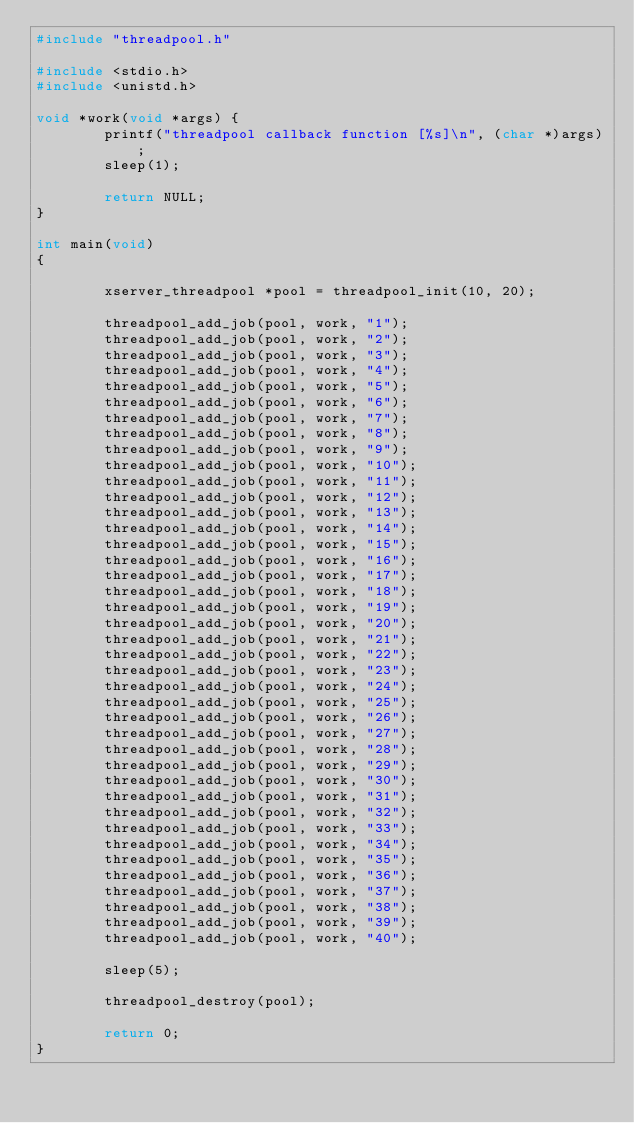<code> <loc_0><loc_0><loc_500><loc_500><_C_>#include "threadpool.h"

#include <stdio.h>
#include <unistd.h>

void *work(void *args) {
        printf("threadpool callback function [%s]\n", (char *)args);
        sleep(1);

        return NULL;
}

int main(void)
{

        xserver_threadpool *pool = threadpool_init(10, 20);

        threadpool_add_job(pool, work, "1");
        threadpool_add_job(pool, work, "2");
        threadpool_add_job(pool, work, "3");
        threadpool_add_job(pool, work, "4");
        threadpool_add_job(pool, work, "5");
        threadpool_add_job(pool, work, "6");
        threadpool_add_job(pool, work, "7");
        threadpool_add_job(pool, work, "8");
        threadpool_add_job(pool, work, "9");
        threadpool_add_job(pool, work, "10");
        threadpool_add_job(pool, work, "11");
        threadpool_add_job(pool, work, "12");
        threadpool_add_job(pool, work, "13");
        threadpool_add_job(pool, work, "14");
        threadpool_add_job(pool, work, "15");
        threadpool_add_job(pool, work, "16");
        threadpool_add_job(pool, work, "17");
        threadpool_add_job(pool, work, "18");
        threadpool_add_job(pool, work, "19");
        threadpool_add_job(pool, work, "20");
        threadpool_add_job(pool, work, "21");
        threadpool_add_job(pool, work, "22");
        threadpool_add_job(pool, work, "23");
        threadpool_add_job(pool, work, "24");
        threadpool_add_job(pool, work, "25");
        threadpool_add_job(pool, work, "26");
        threadpool_add_job(pool, work, "27");
        threadpool_add_job(pool, work, "28");
        threadpool_add_job(pool, work, "29");
        threadpool_add_job(pool, work, "30");
        threadpool_add_job(pool, work, "31");
        threadpool_add_job(pool, work, "32");
        threadpool_add_job(pool, work, "33");
        threadpool_add_job(pool, work, "34");
        threadpool_add_job(pool, work, "35");
        threadpool_add_job(pool, work, "36");
        threadpool_add_job(pool, work, "37");
        threadpool_add_job(pool, work, "38");
        threadpool_add_job(pool, work, "39");
        threadpool_add_job(pool, work, "40");

        sleep(5);

        threadpool_destroy(pool);

        return 0;
}
</code> 